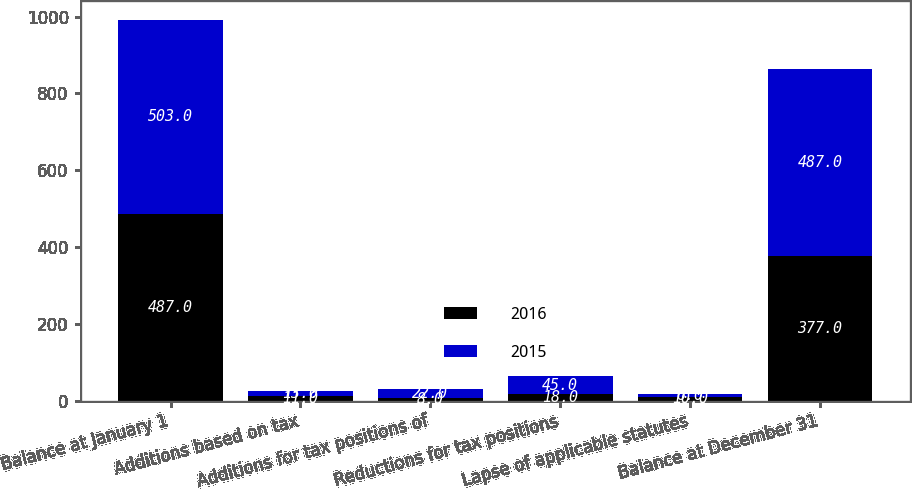<chart> <loc_0><loc_0><loc_500><loc_500><stacked_bar_chart><ecel><fcel>Balance at January 1<fcel>Additions based on tax<fcel>Additions for tax positions of<fcel>Reductions for tax positions<fcel>Lapse of applicable statutes<fcel>Balance at December 31<nl><fcel>2016<fcel>487<fcel>11<fcel>8<fcel>18<fcel>10<fcel>377<nl><fcel>2015<fcel>503<fcel>13<fcel>22<fcel>45<fcel>6<fcel>487<nl></chart> 